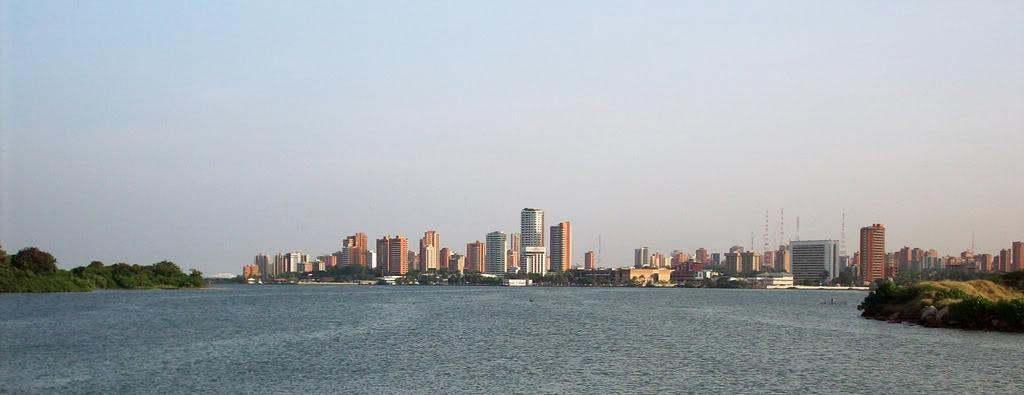What can be seen in the background of the image? There are buildings, trees, and the sky visible in the background of the image. What is located at the bottom of the image? There is water at the bottom of the image. Where is the cat sitting on the sofa in the image? There is no cat or sofa present in the image. How much butter is visible in the image? There is no butter present in the image. 